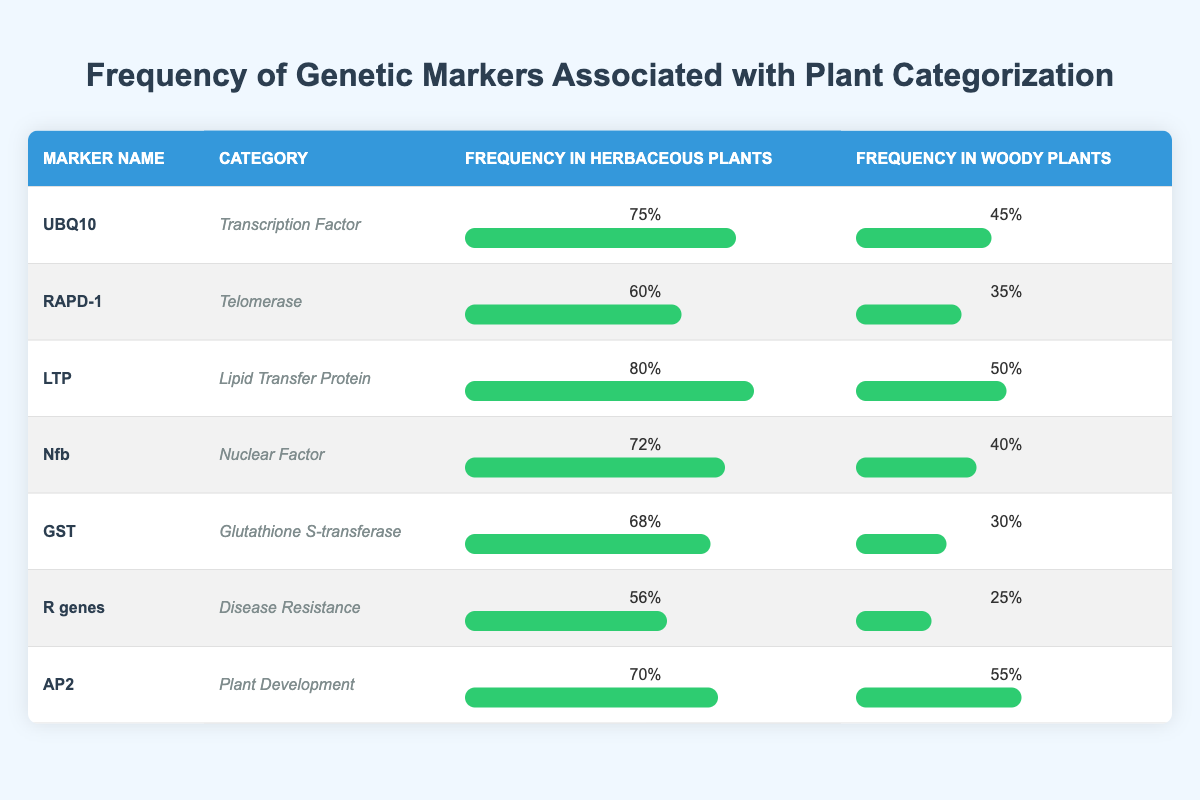What is the frequency of the genetic marker UBQ10 in herbaceous plants? The frequency of the genetic marker UBQ10 in herbaceous plants is clearly listed in the table under the "Frequency in Herbaceous Plants" column. That value is 75%.
Answer: 75% What is the category of the genetic marker LTP? The table specifies the category of each genetic marker in the "Category" column. For LTP, the category is "Lipid Transfer Protein."
Answer: Lipid Transfer Protein Which genetic marker has the highest frequency in woody plants? By scanning through the "Frequency in Woody Plants" column, we find that LTP has the highest frequency at 50%.
Answer: LTP Is the frequency of genetic markers generally higher in herbaceous plants or woody plants? To determine this, we can compare the average frequencies of both groups. The average for herbaceous plants is (0.75 + 0.60 + 0.80 + 0.72 + 0.68 + 0.56 + 0.70) / 7 = 0.6843, and the average for woody plants is (0.45 + 0.35 + 0.50 + 0.40 + 0.30 + 0.25 + 0.55) / 7 = 0.3929. Since 0.6843 is greater than 0.3929, we conclude that genetic markers generally have higher frequencies in herbaceous plants.
Answer: Herbaceous plants What is the difference in frequency of the genetic marker R genes between herbaceous and woody plants? To find the difference, we subtract the frequency in woody plants (0.25) from the frequency in herbaceous plants (0.56): 0.56 - 0.25 = 0.31. The frequency difference is therefore 0.31.
Answer: 0.31 Does the genetic marker GST have a higher frequency in herbaceous plants compared to Nfb? Looking at the specific frequencies, GST in herbaceous plants has a frequency of 0.68 while Nfb has a frequency of 0.72 in herbaceous plants. Since 0.68 is not greater than 0.72, the statement is false.
Answer: No What is the average frequency of the genetic markers categorized under disease resistance? The only genetic marker listed under disease resistance is R genes. Its frequency in herbaceous plants is 0.56, and in woody plants, it is 0.25. To find the average: (0.56 + 0.25) / 2 = 0.405.
Answer: 0.405 Which categories of genetic markers have frequencies above 70% in herbaceous plants? We need to look through the "Frequency in Herbaceous Plants" column for values greater than 0.70. The categories that meet this criterion are "Transcription Factor" (UBQ10), "Lipid Transfer Protein" (LTP), "Nuclear Factor" (Nfb), and "Plant Development" (AP2).
Answer: Transcription Factor, Lipid Transfer Protein, Nuclear Factor, Plant Development What percentage of woody plant genetic markers have a frequency of less than 30%? Reviewing the "Frequency in Woody Plants" column, we find that GST (0.30), R genes (0.25), and RAPD-1 (0.35) are relevant. Only R genes falls below 30%. Thus, 1 out of 7 markers, which results in approximately 14.29%.
Answer: 14.29% 